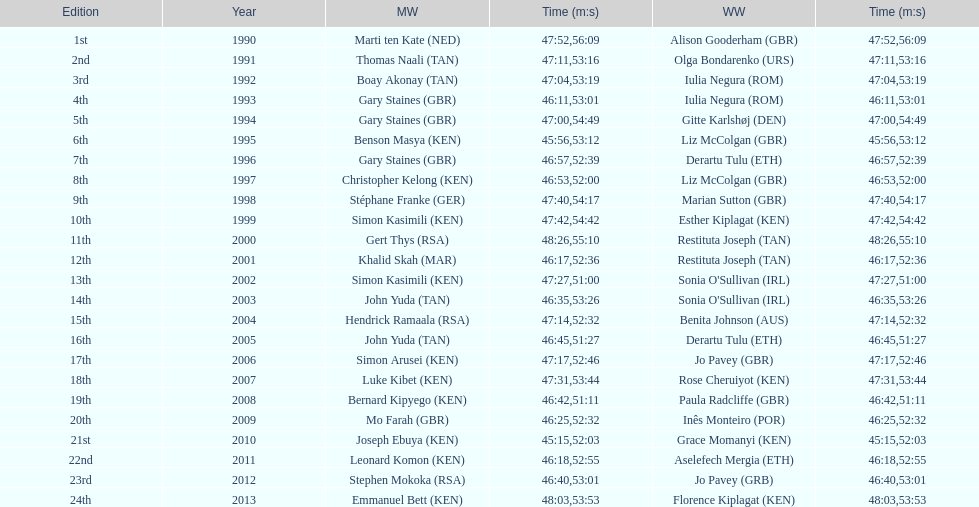What is the difference in finishing times for the men's and women's bupa great south run finish for 2013? 5:50. 